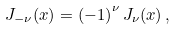<formula> <loc_0><loc_0><loc_500><loc_500>J _ { - \nu } ( x ) = \left ( - 1 \right ) ^ { \nu } J _ { \nu } ( x ) \, ,</formula> 